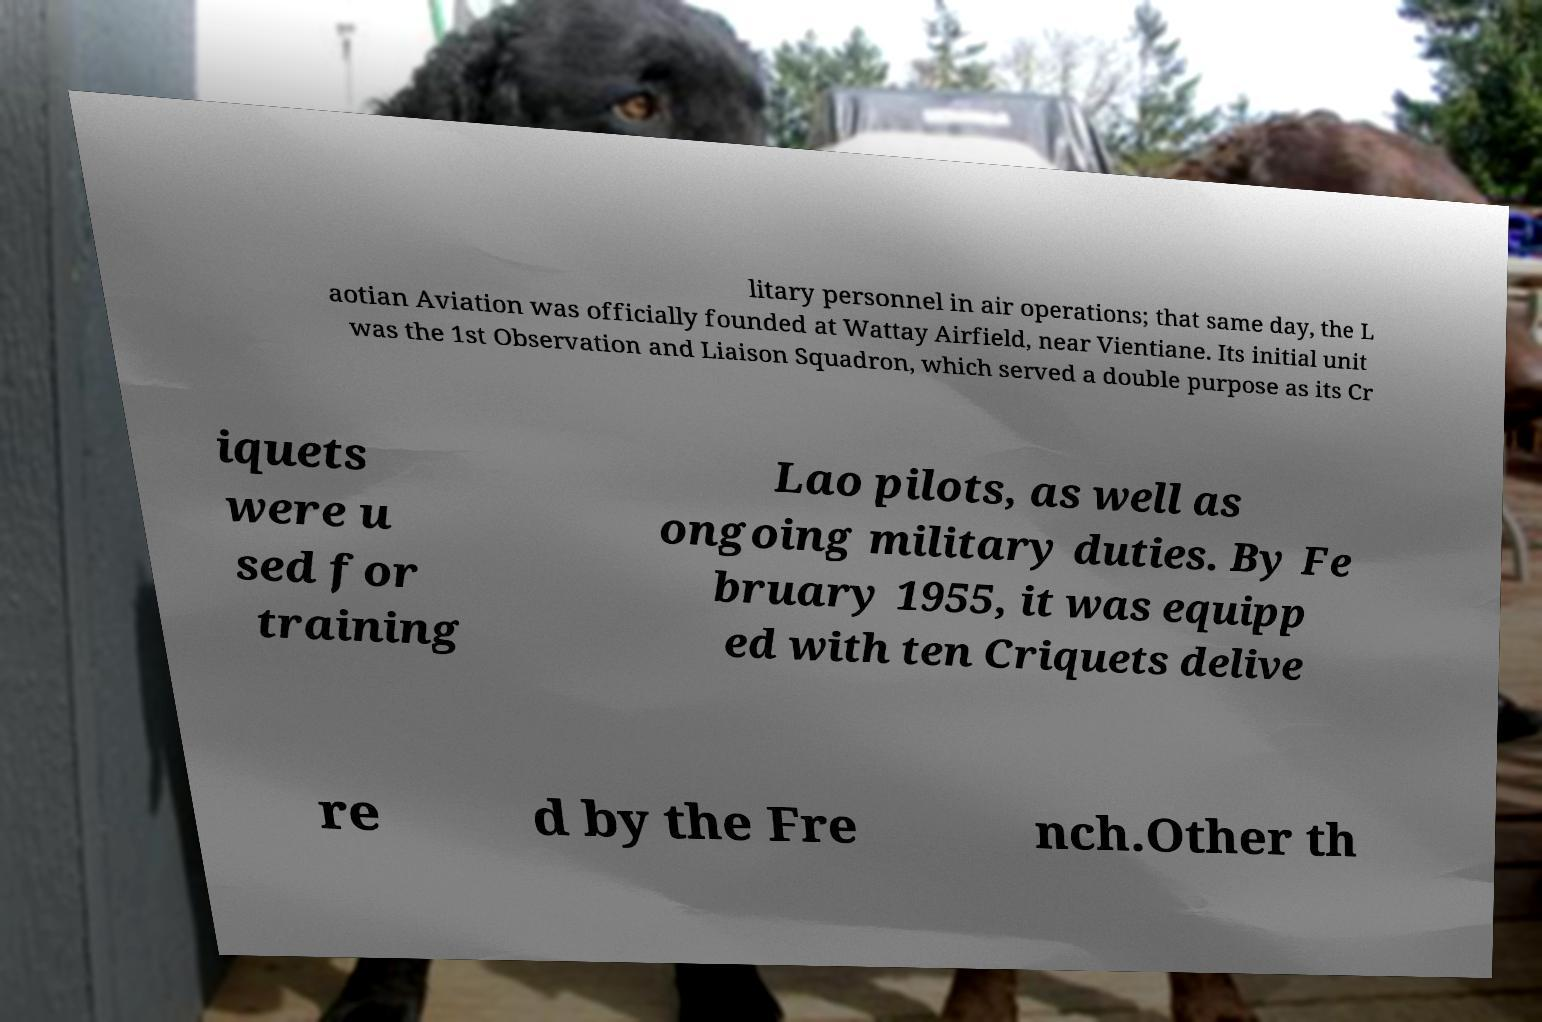What messages or text are displayed in this image? I need them in a readable, typed format. litary personnel in air operations; that same day, the L aotian Aviation was officially founded at Wattay Airfield, near Vientiane. Its initial unit was the 1st Observation and Liaison Squadron, which served a double purpose as its Cr iquets were u sed for training Lao pilots, as well as ongoing military duties. By Fe bruary 1955, it was equipp ed with ten Criquets delive re d by the Fre nch.Other th 